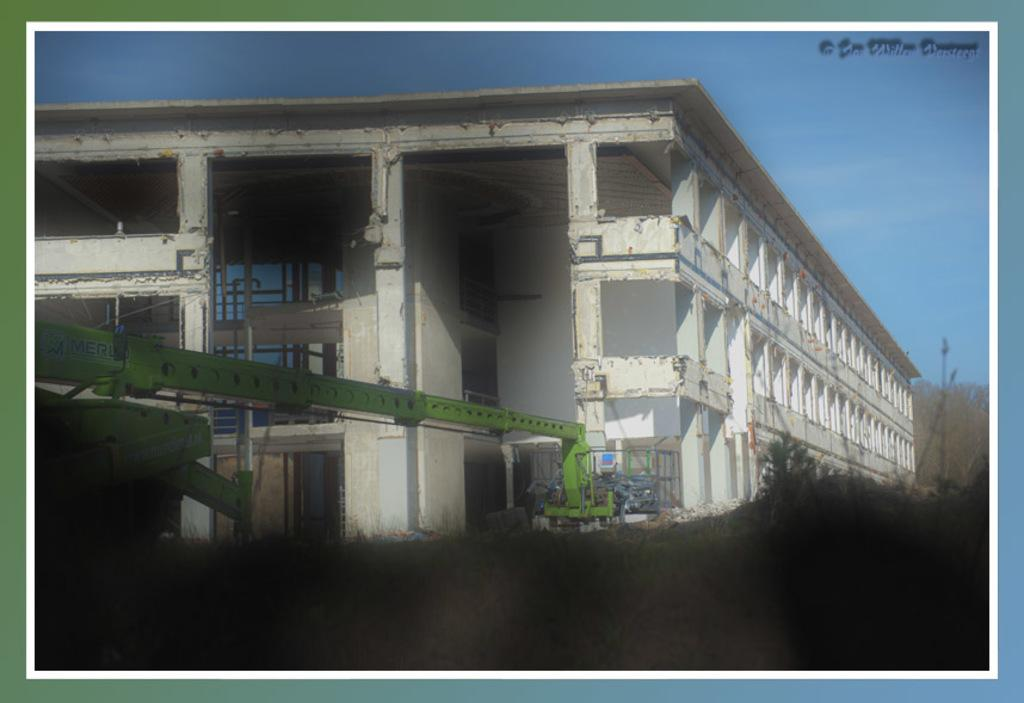What is the main subject of the image? There is a crane in the image. What color is the crane? The crane is green. What can be seen in the background of the image? There is a building and trees in the background of the image. What color is the building? The building is white. What color are the trees? The trees are green. What color is the sky in the image? The sky is blue. What type of rice is being cooked in the background of the image? There is no rice present in the image; it features a green crane, a white building, green trees, and a blue sky. What song is being sung by the crane in the image? There is no indication of a song being sung by the crane in the image. 